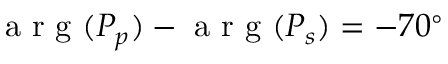<formula> <loc_0><loc_0><loc_500><loc_500>a r g ( P _ { p } ) - a r g ( P _ { s } ) = - 7 0 ^ { \circ }</formula> 